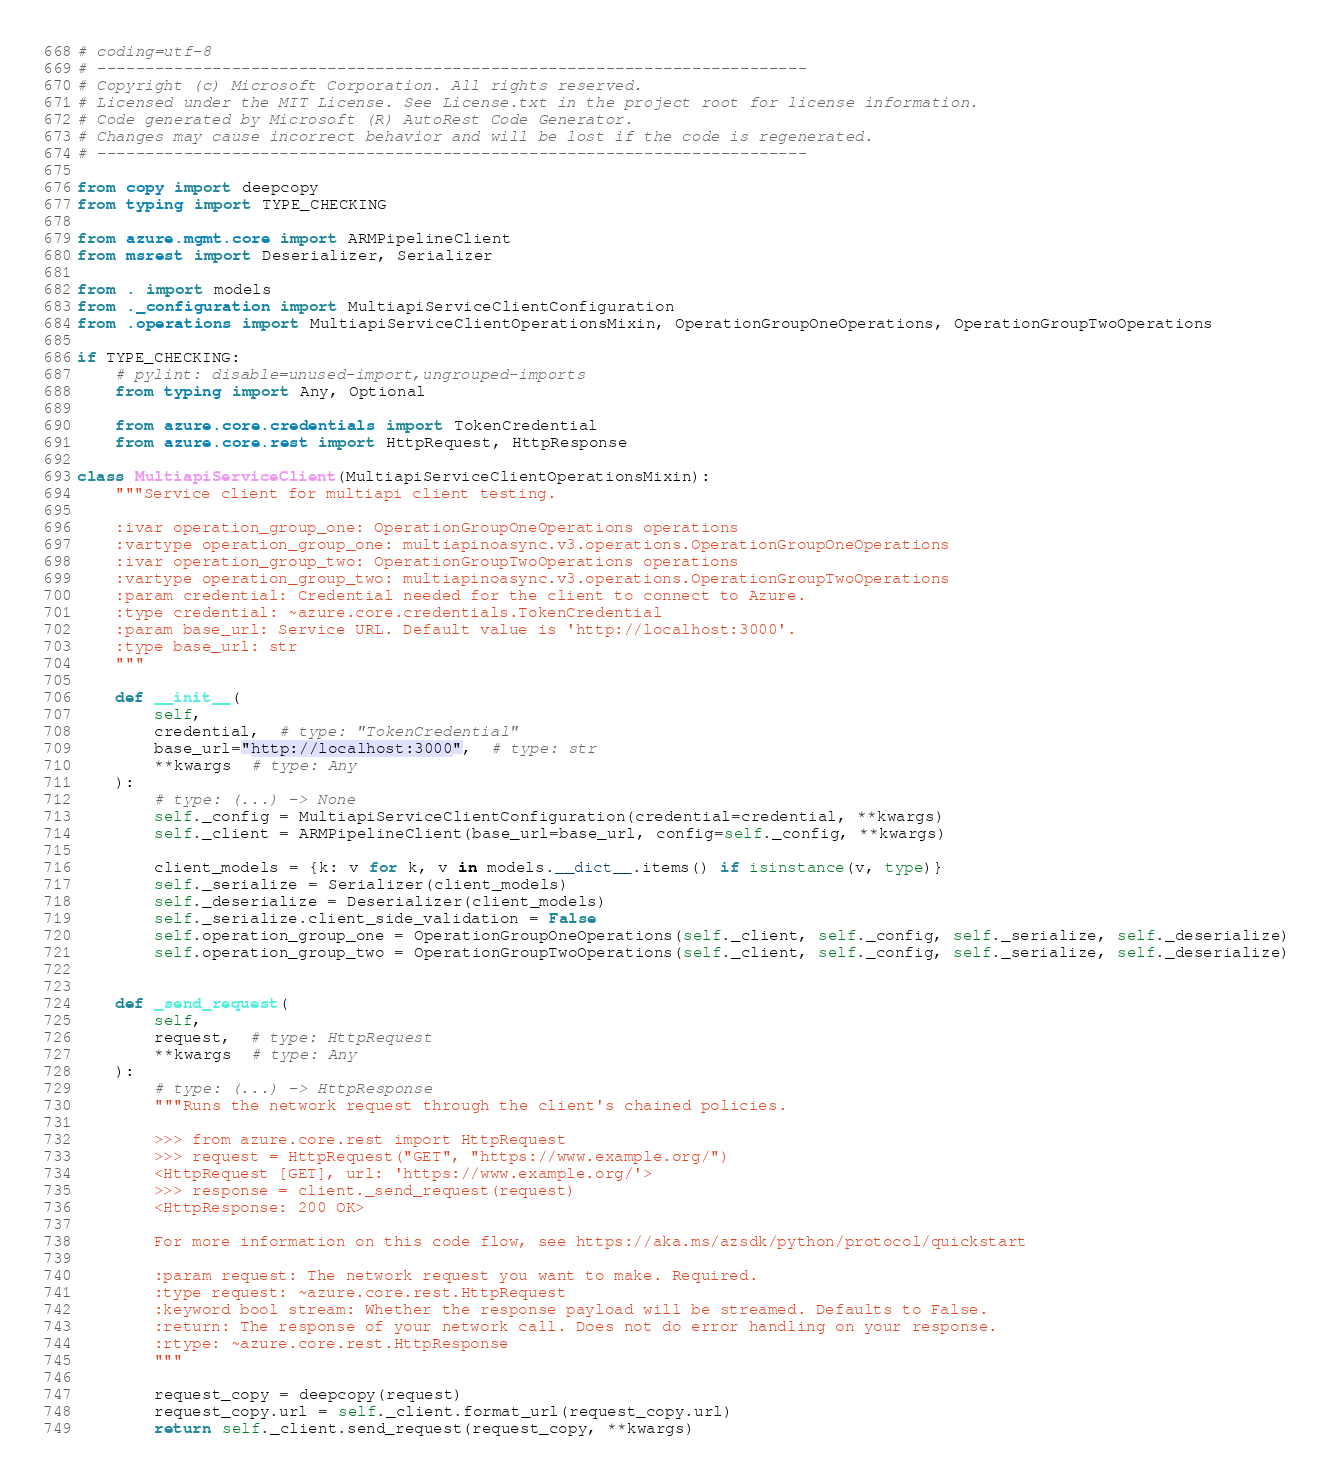Convert code to text. <code><loc_0><loc_0><loc_500><loc_500><_Python_># coding=utf-8
# --------------------------------------------------------------------------
# Copyright (c) Microsoft Corporation. All rights reserved.
# Licensed under the MIT License. See License.txt in the project root for license information.
# Code generated by Microsoft (R) AutoRest Code Generator.
# Changes may cause incorrect behavior and will be lost if the code is regenerated.
# --------------------------------------------------------------------------

from copy import deepcopy
from typing import TYPE_CHECKING

from azure.mgmt.core import ARMPipelineClient
from msrest import Deserializer, Serializer

from . import models
from ._configuration import MultiapiServiceClientConfiguration
from .operations import MultiapiServiceClientOperationsMixin, OperationGroupOneOperations, OperationGroupTwoOperations

if TYPE_CHECKING:
    # pylint: disable=unused-import,ungrouped-imports
    from typing import Any, Optional

    from azure.core.credentials import TokenCredential
    from azure.core.rest import HttpRequest, HttpResponse

class MultiapiServiceClient(MultiapiServiceClientOperationsMixin):
    """Service client for multiapi client testing.

    :ivar operation_group_one: OperationGroupOneOperations operations
    :vartype operation_group_one: multiapinoasync.v3.operations.OperationGroupOneOperations
    :ivar operation_group_two: OperationGroupTwoOperations operations
    :vartype operation_group_two: multiapinoasync.v3.operations.OperationGroupTwoOperations
    :param credential: Credential needed for the client to connect to Azure.
    :type credential: ~azure.core.credentials.TokenCredential
    :param base_url: Service URL. Default value is 'http://localhost:3000'.
    :type base_url: str
    """

    def __init__(
        self,
        credential,  # type: "TokenCredential"
        base_url="http://localhost:3000",  # type: str
        **kwargs  # type: Any
    ):
        # type: (...) -> None
        self._config = MultiapiServiceClientConfiguration(credential=credential, **kwargs)
        self._client = ARMPipelineClient(base_url=base_url, config=self._config, **kwargs)

        client_models = {k: v for k, v in models.__dict__.items() if isinstance(v, type)}
        self._serialize = Serializer(client_models)
        self._deserialize = Deserializer(client_models)
        self._serialize.client_side_validation = False
        self.operation_group_one = OperationGroupOneOperations(self._client, self._config, self._serialize, self._deserialize)
        self.operation_group_two = OperationGroupTwoOperations(self._client, self._config, self._serialize, self._deserialize)


    def _send_request(
        self,
        request,  # type: HttpRequest
        **kwargs  # type: Any
    ):
        # type: (...) -> HttpResponse
        """Runs the network request through the client's chained policies.

        >>> from azure.core.rest import HttpRequest
        >>> request = HttpRequest("GET", "https://www.example.org/")
        <HttpRequest [GET], url: 'https://www.example.org/'>
        >>> response = client._send_request(request)
        <HttpResponse: 200 OK>

        For more information on this code flow, see https://aka.ms/azsdk/python/protocol/quickstart

        :param request: The network request you want to make. Required.
        :type request: ~azure.core.rest.HttpRequest
        :keyword bool stream: Whether the response payload will be streamed. Defaults to False.
        :return: The response of your network call. Does not do error handling on your response.
        :rtype: ~azure.core.rest.HttpResponse
        """

        request_copy = deepcopy(request)
        request_copy.url = self._client.format_url(request_copy.url)
        return self._client.send_request(request_copy, **kwargs)
</code> 